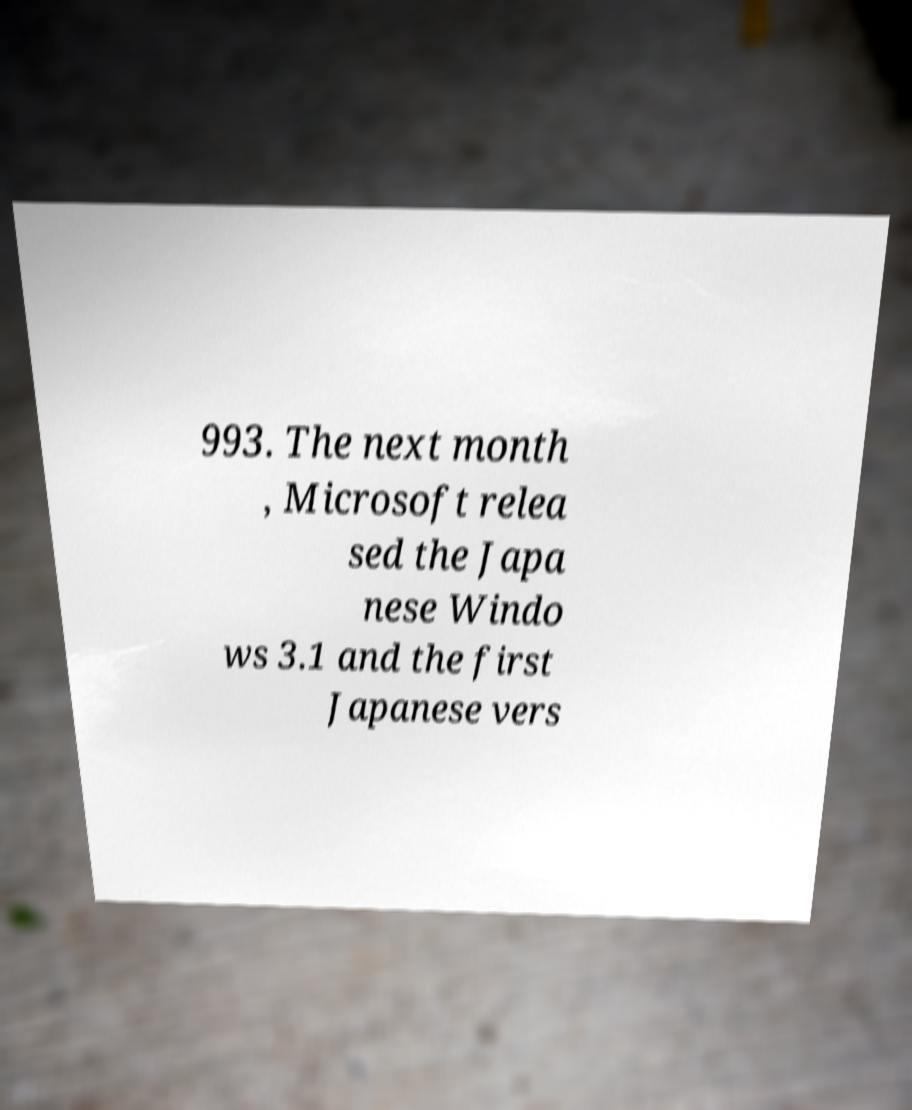Please read and relay the text visible in this image. What does it say? 993. The next month , Microsoft relea sed the Japa nese Windo ws 3.1 and the first Japanese vers 